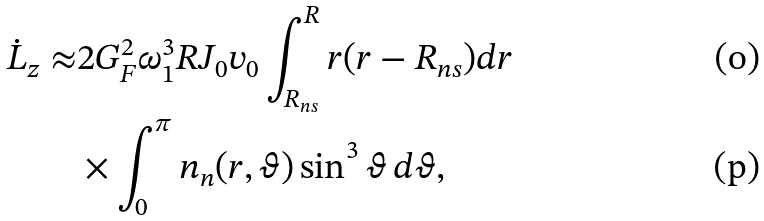<formula> <loc_0><loc_0><loc_500><loc_500>\dot { L } _ { z } \approx & 2 G _ { F } ^ { 2 } \omega _ { 1 } ^ { 3 } R J _ { 0 } v _ { 0 } \int _ { R _ { n s } } ^ { R } r ( r - R _ { n s } ) d r \\ & \times \int _ { 0 } ^ { \pi } n _ { n } ( r , \vartheta ) \sin ^ { 3 } \vartheta \, d \vartheta ,</formula> 